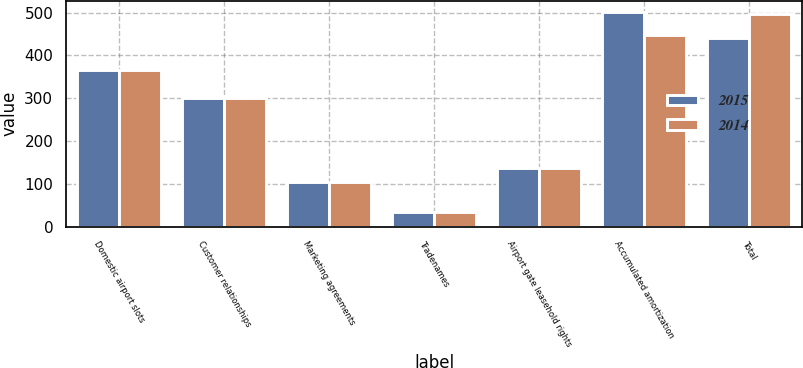<chart> <loc_0><loc_0><loc_500><loc_500><stacked_bar_chart><ecel><fcel>Domestic airport slots<fcel>Customer relationships<fcel>Marketing agreements<fcel>Tradenames<fcel>Airport gate leasehold rights<fcel>Accumulated amortization<fcel>Total<nl><fcel>2015<fcel>365<fcel>300<fcel>105<fcel>35<fcel>137<fcel>502<fcel>440<nl><fcel>2014<fcel>365<fcel>300<fcel>105<fcel>35<fcel>138<fcel>447<fcel>496<nl></chart> 